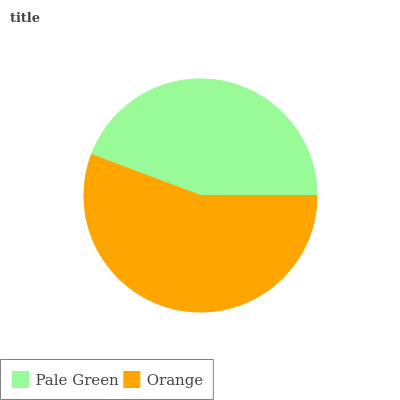Is Pale Green the minimum?
Answer yes or no. Yes. Is Orange the maximum?
Answer yes or no. Yes. Is Orange the minimum?
Answer yes or no. No. Is Orange greater than Pale Green?
Answer yes or no. Yes. Is Pale Green less than Orange?
Answer yes or no. Yes. Is Pale Green greater than Orange?
Answer yes or no. No. Is Orange less than Pale Green?
Answer yes or no. No. Is Orange the high median?
Answer yes or no. Yes. Is Pale Green the low median?
Answer yes or no. Yes. Is Pale Green the high median?
Answer yes or no. No. Is Orange the low median?
Answer yes or no. No. 